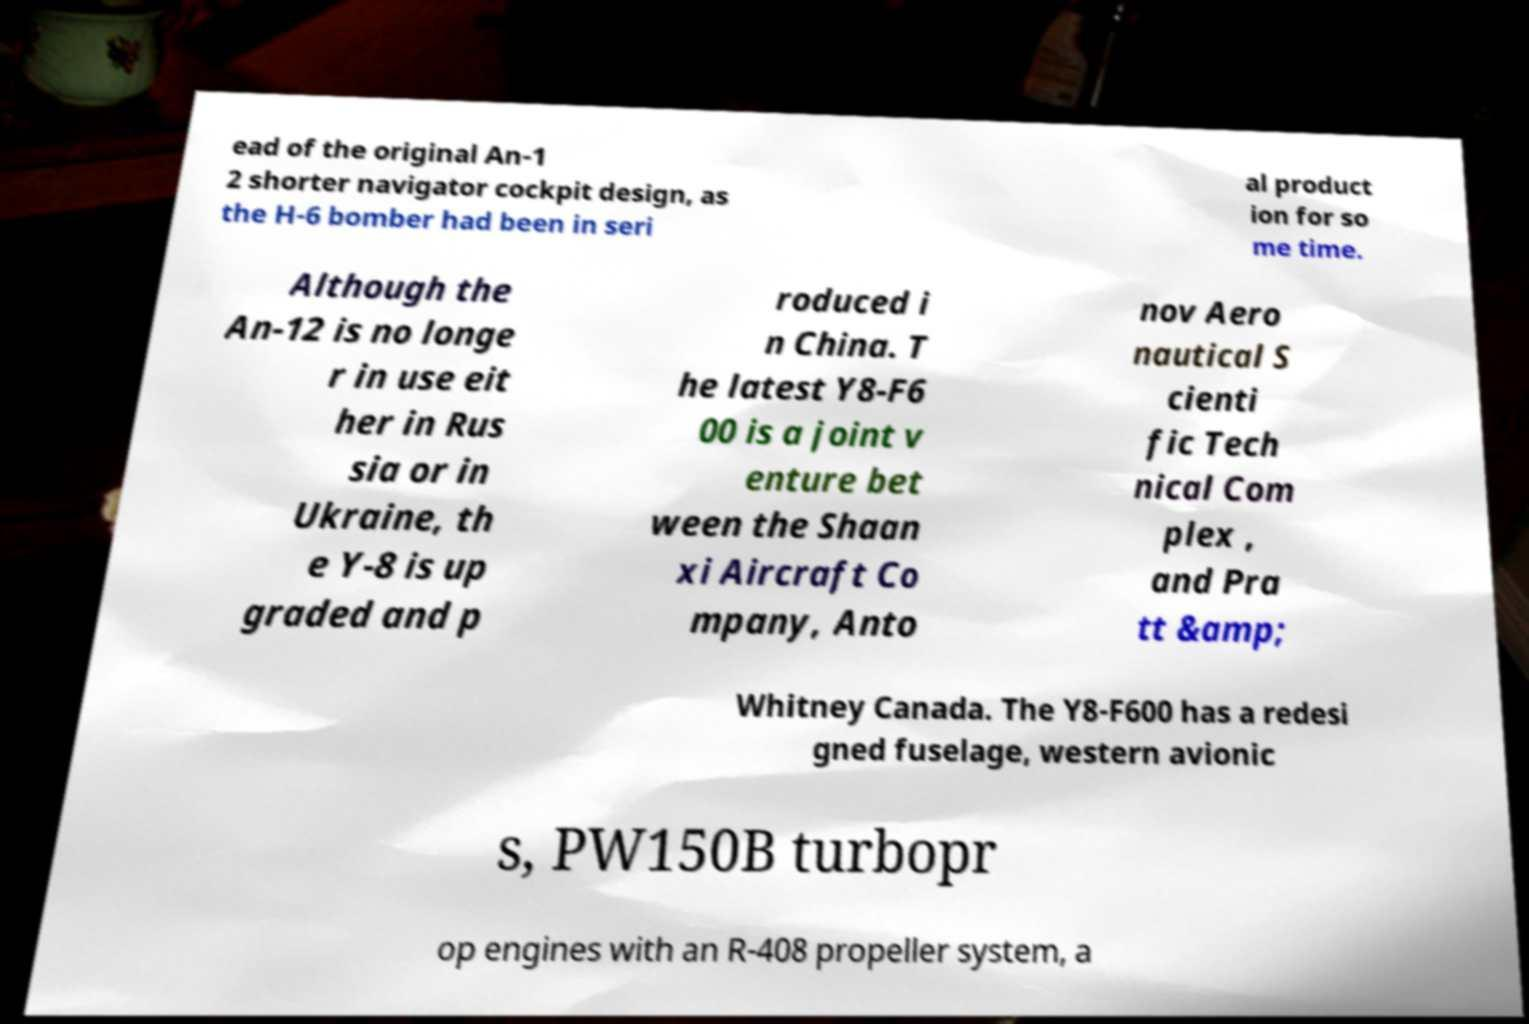Please identify and transcribe the text found in this image. ead of the original An-1 2 shorter navigator cockpit design, as the H-6 bomber had been in seri al product ion for so me time. Although the An-12 is no longe r in use eit her in Rus sia or in Ukraine, th e Y-8 is up graded and p roduced i n China. T he latest Y8-F6 00 is a joint v enture bet ween the Shaan xi Aircraft Co mpany, Anto nov Aero nautical S cienti fic Tech nical Com plex , and Pra tt &amp; Whitney Canada. The Y8-F600 has a redesi gned fuselage, western avionic s, PW150B turbopr op engines with an R-408 propeller system, a 